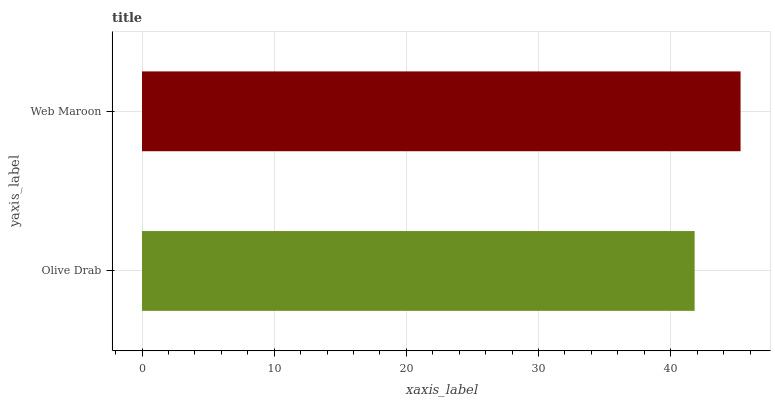Is Olive Drab the minimum?
Answer yes or no. Yes. Is Web Maroon the maximum?
Answer yes or no. Yes. Is Web Maroon the minimum?
Answer yes or no. No. Is Web Maroon greater than Olive Drab?
Answer yes or no. Yes. Is Olive Drab less than Web Maroon?
Answer yes or no. Yes. Is Olive Drab greater than Web Maroon?
Answer yes or no. No. Is Web Maroon less than Olive Drab?
Answer yes or no. No. Is Web Maroon the high median?
Answer yes or no. Yes. Is Olive Drab the low median?
Answer yes or no. Yes. Is Olive Drab the high median?
Answer yes or no. No. Is Web Maroon the low median?
Answer yes or no. No. 